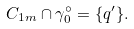<formula> <loc_0><loc_0><loc_500><loc_500>C _ { 1 m } \cap \gamma _ { 0 } ^ { \circ } = \{ q ^ { \prime } \} .</formula> 